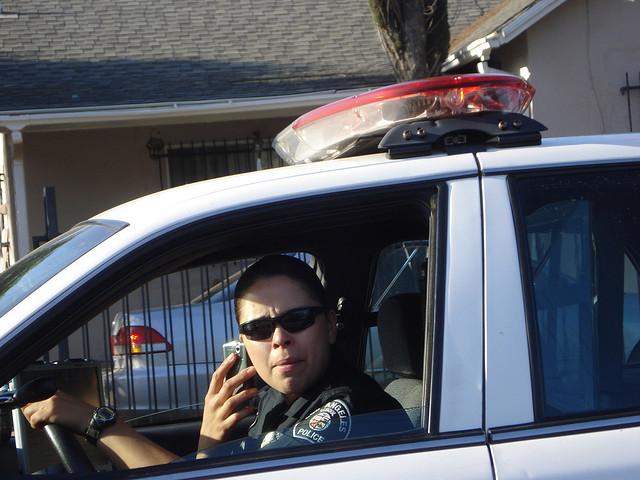How many windows can be seen on the house in the background?
Short answer required. 1. Who is in glasses?
Be succinct. Police officer. What is their occupation?
Keep it brief. Police. 